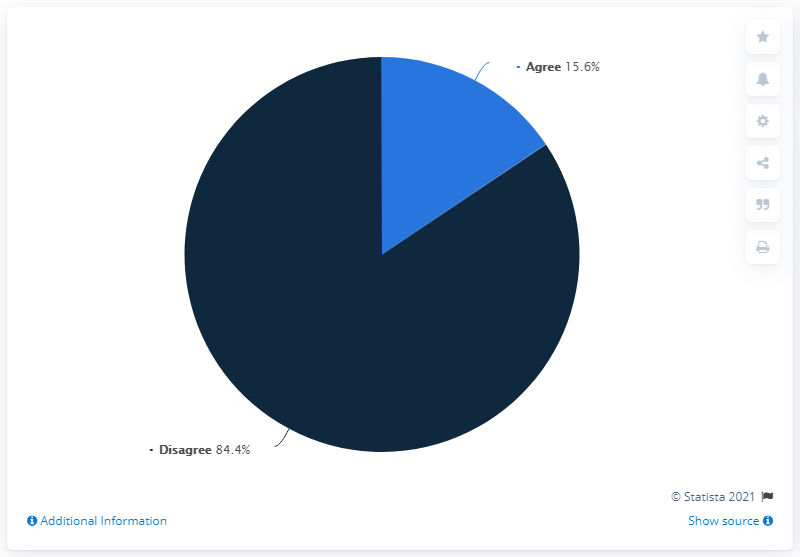Highlight a few significant elements in this photo. 15.6% of people agree... The ratio of disagree to agree is 5.41. 